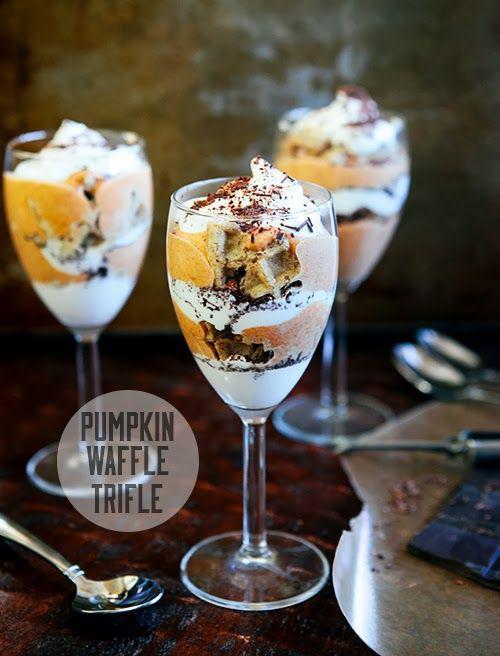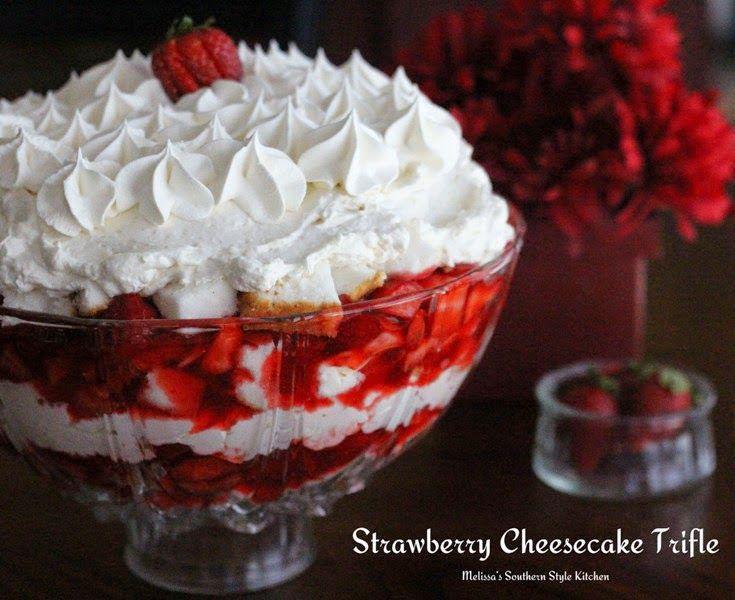The first image is the image on the left, the second image is the image on the right. Assess this claim about the two images: "One of the images features three trifle desserts served individually.". Correct or not? Answer yes or no. Yes. 